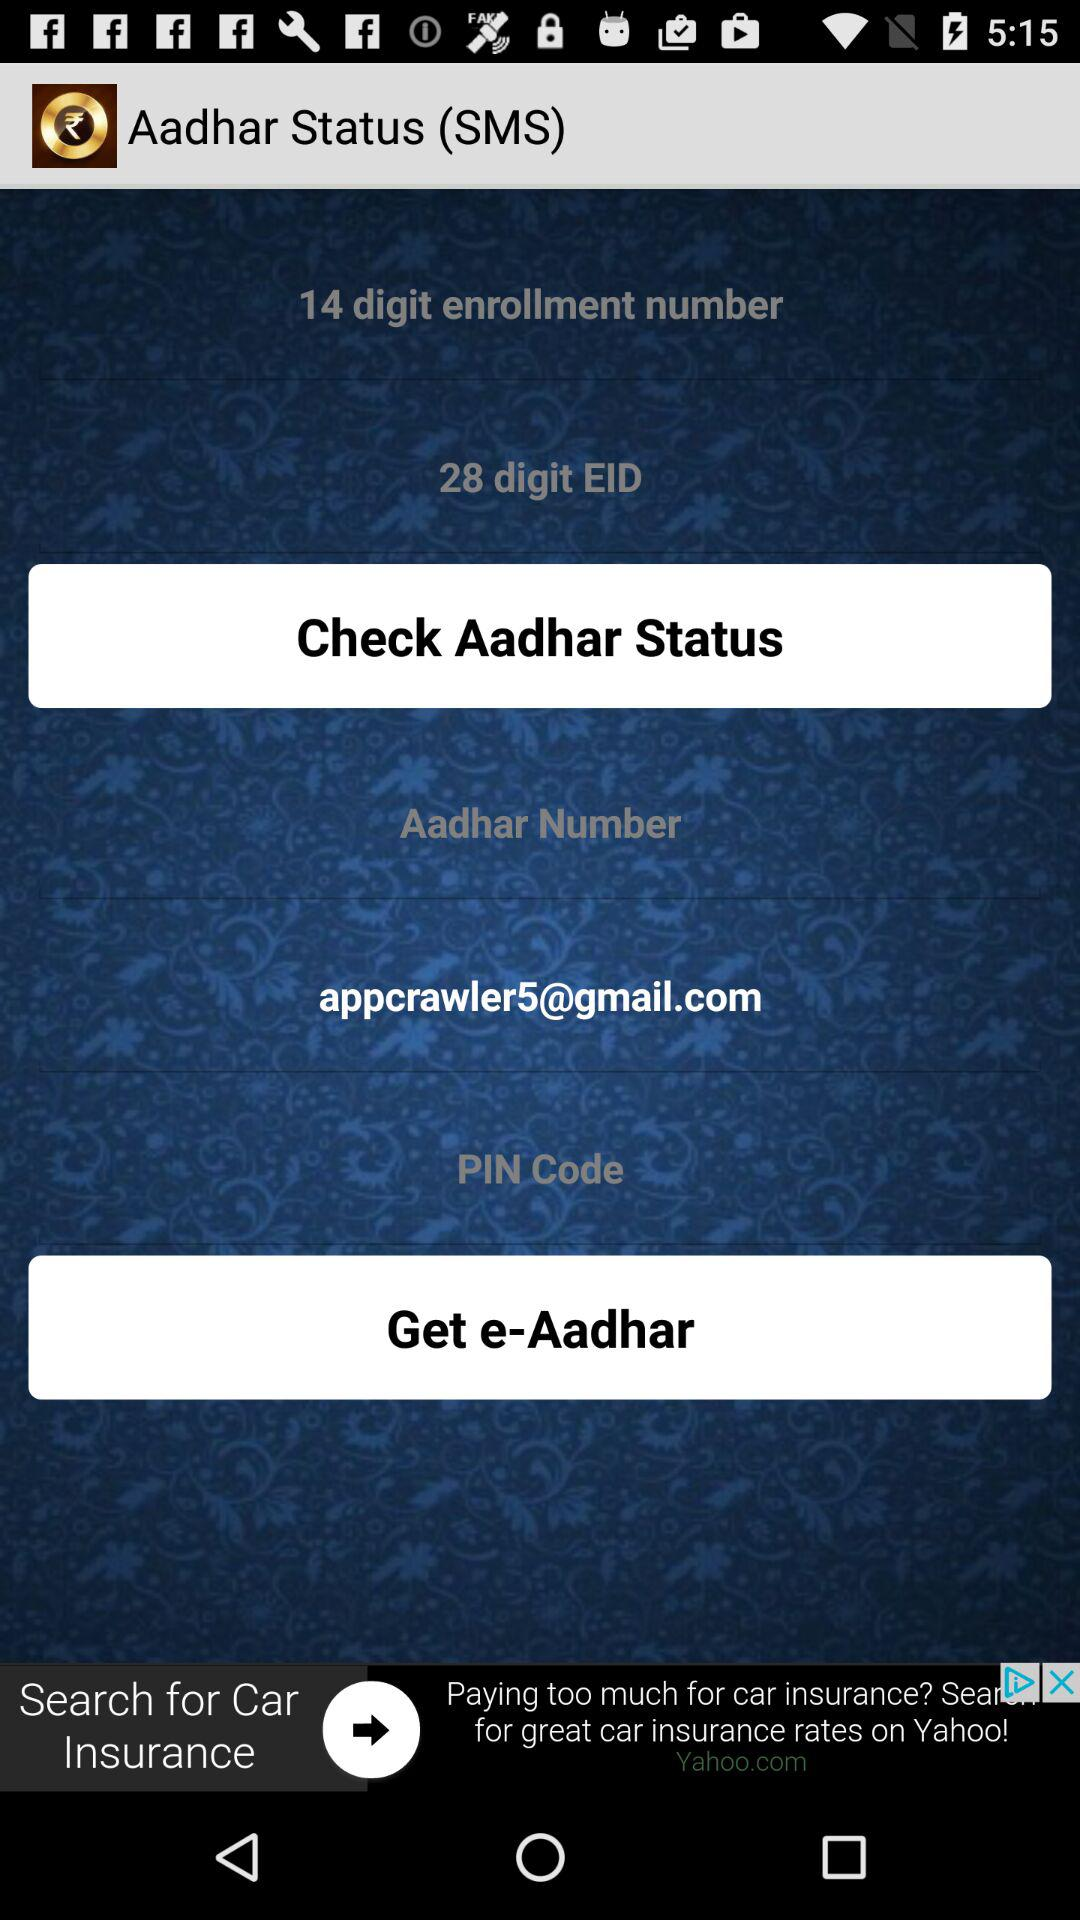What is the number of digits in the EID? The number of digits in the EID is 28. 